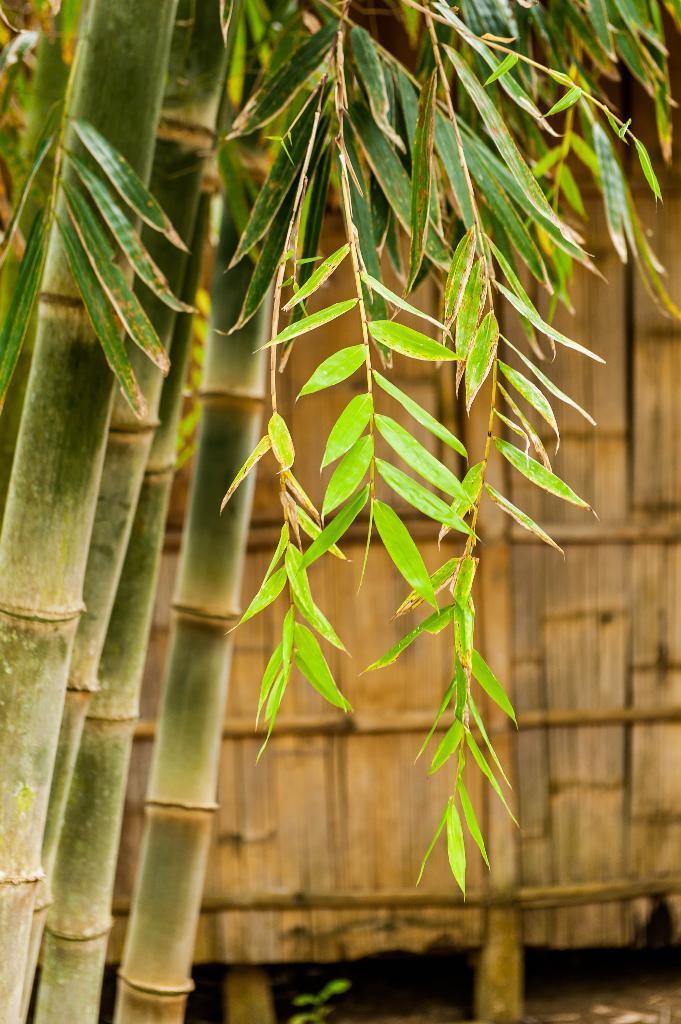How would you summarize this image in a sentence or two? In this image I can see the trees. In the back I can see the wooden wall which is in brown color. 